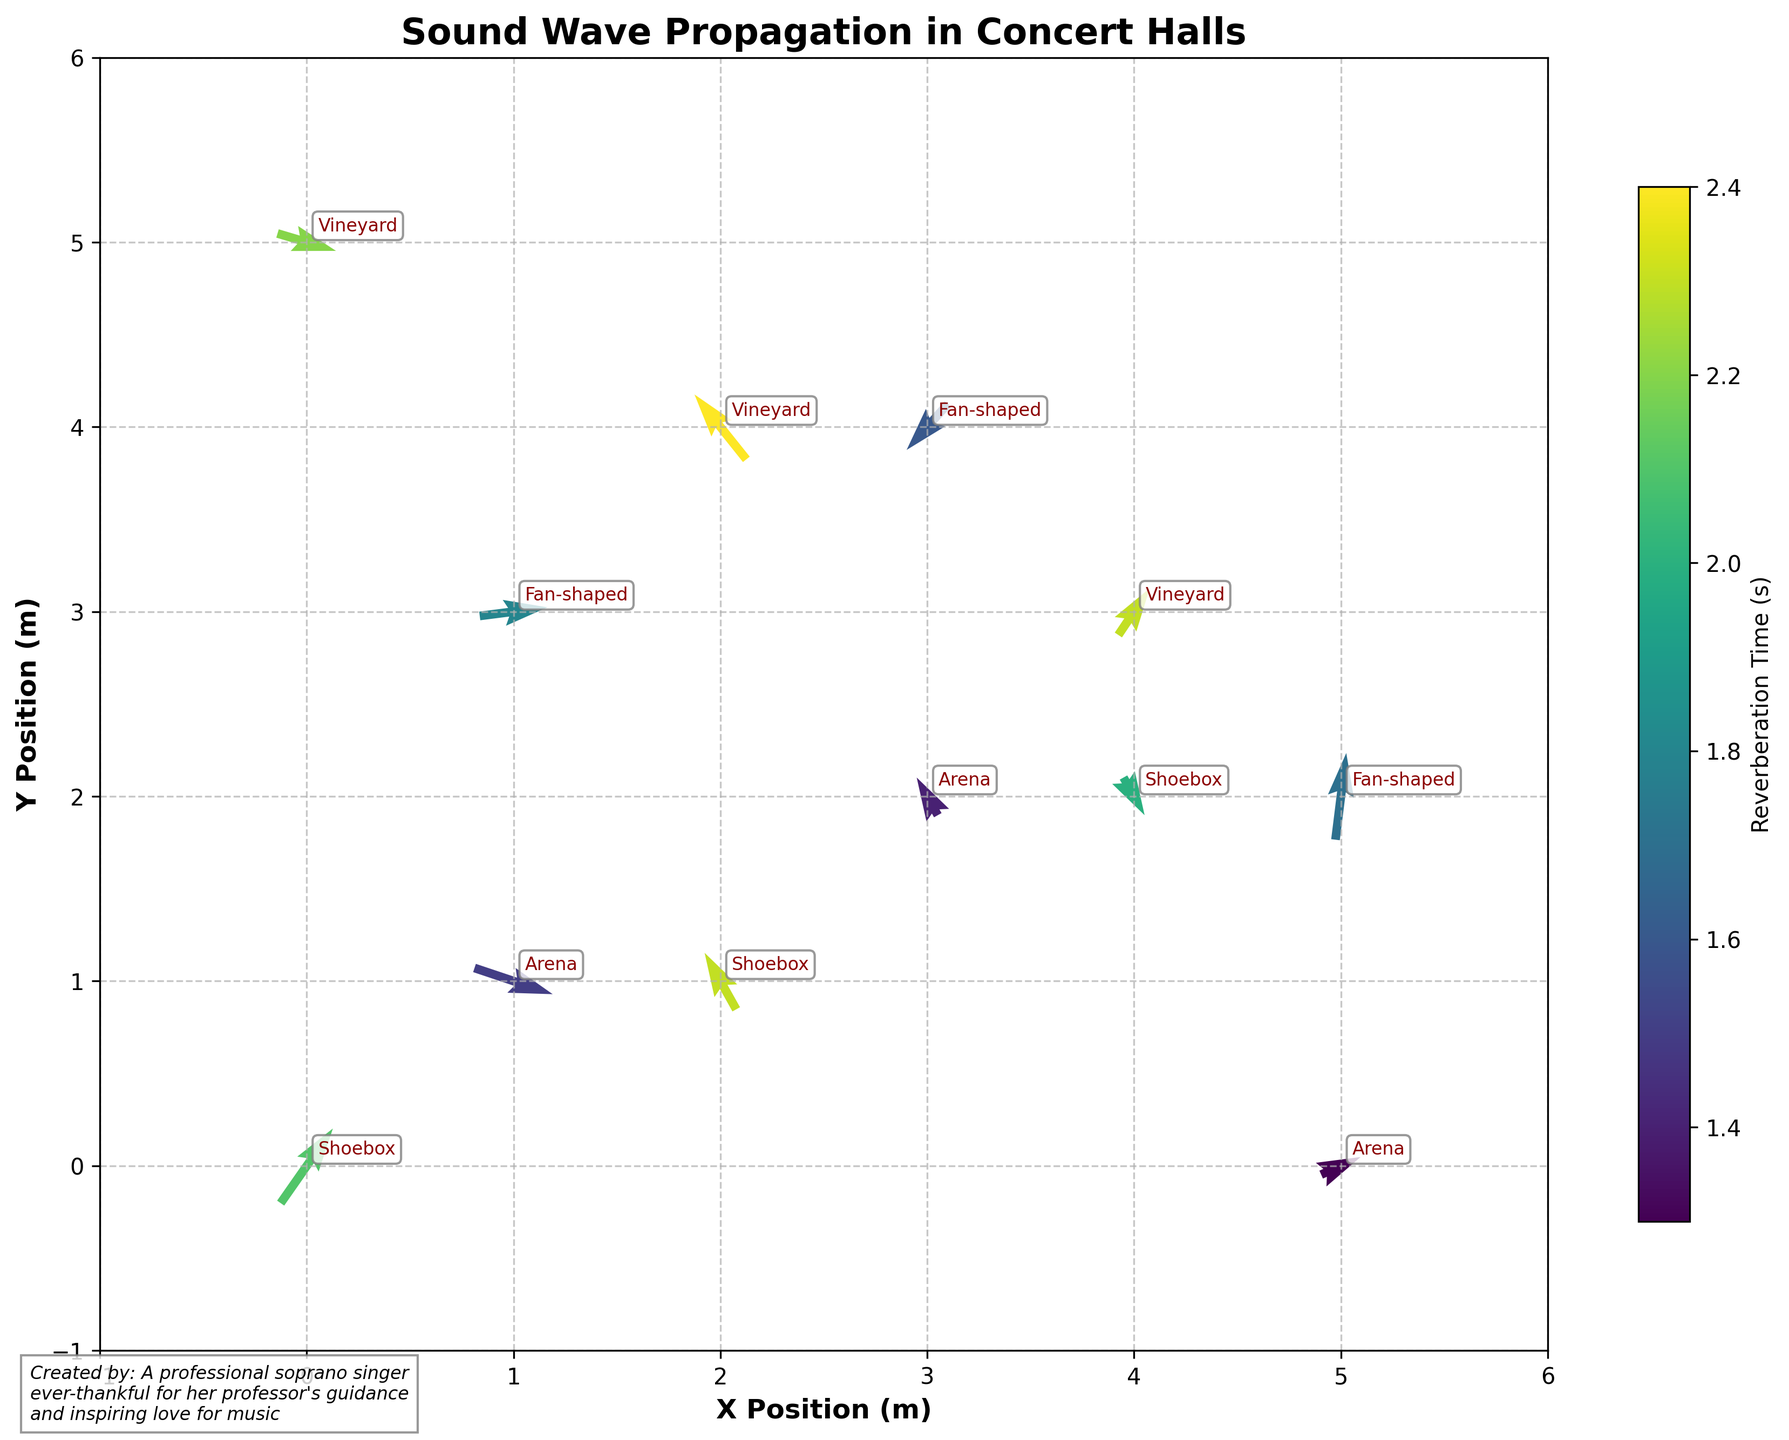How is the axis labeled on the plot? The x-axis and y-axis are labeled with positions in meters. Specifically, the x-axis is labeled as "X Position (m)" and the y-axis is labeled as "Y Position (m)."
Answer: X Position (m) and Y Position (m) What is the title of the plot? The title of the plot is displayed at the top in bold text. It provides an immediate understanding of what the plot depicts. According to the detailed description, the title is "Sound Wave Propagation in Concert Halls."
Answer: Sound Wave Propagation in Concert Halls How many different concert hall designs are represented in the plot? According to the annotations in the plot, there are four different concert hall designs labeled beside the quiver points. These are Shoebox, Fan-shaped, Vineyard, and Arena.
Answer: Four Which concert hall design has the highest reverberation time? The color map representing reverberation time indicates different values. Upon examining the colors, Vineyard has a notably darker shade indicating higher reverberation times. Specifically, Vineyard has the highest average or maximum reverberation time at around 2.4 seconds.
Answer: Vineyard Among the Arena and Shoebox hall types, which one has the vectors more generally pointing upwards? By comparing the direction of vectors associated with the respective hall types, it is seen that Shoebox has more vectors generally pointing upwards (example: vectors at (0,0) with direction 0.5,0.8 and (2,1) with direction -0.3,0.6), while Arena has fewer and smaller upward vectors.
Answer: Shoebox What observable patterns can be seen about the direction of sound waves in different hall designs? By examining the direction of vectors, we can infer that Vineyard and Shoebox concert halls have more upward vectors, indicating better sound wave distribution towards the back upper areas, Arena shows vectors slightly tilted upward but more oriented horizontally, and Fan-shaped hall has more downward or sideways vectors indicating uneven sound wave patterns.
Answer: Vineyard and Shoebox have more upward vectors; Fan-shaped has more downward or sideways vectors What is the average reverberation time for the Shoebox concert hall design? There are three data points for Shoebox with reverberation times 2.1, 2.3, and 2.0. Summing these gives 6.4. Dividing by the number of observations, which is 3, results in 2.13.
Answer: 2.13 Considering hall types and reverberation time, which hall type shows the most variation? By observing the color variations among vectors for different hall types, it is evident that Shoebox and Vineyard display greater variations in their color intensities, indicating a higher range of reverberation times compared to more consistent colors for Arena and Fan-shaped types. Vineyard shows higher variations ranging from 2.2 to 2.4 seconds.
Answer: Vineyard How is the reverberation time represented in the plot? Reverberation time is represented using a color map (viridis) that shades the vectors. Darker shades represent higher reverberation times, while lighter shades represent lower times. A color bar on the side of the plot provides a scale for reference.
Answer: Color map (viridis) How many vectors belong to each concert hall design? By counting the annotations next to each data point, the Shoebox concert hall design has 3 vectors, the Fan-shaped hall has 3 vectors, the Vineyard concert hall has 3 vectors, and the Arena hall has 3 vectors.
Answer: Each hall type has 3 vectors 